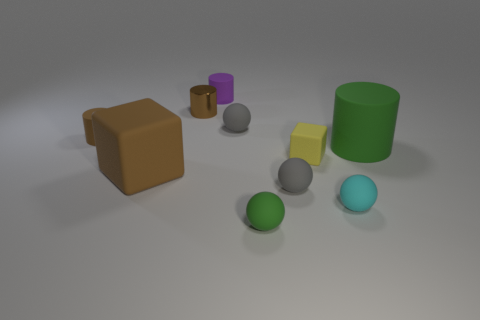Is there a red metal cube that has the same size as the yellow cube?
Your answer should be very brief. No. There is a cyan matte object; is it the same size as the cylinder to the right of the tiny purple rubber object?
Make the answer very short. No. Is the number of small metallic things in front of the cyan matte thing the same as the number of big green objects that are left of the purple rubber object?
Offer a very short reply. Yes. There is a tiny rubber thing that is the same color as the big cylinder; what is its shape?
Your answer should be very brief. Sphere. What is the green object behind the cyan object made of?
Give a very brief answer. Rubber. Does the brown metallic cylinder have the same size as the green matte sphere?
Give a very brief answer. Yes. Are there more things in front of the small purple cylinder than tiny yellow spheres?
Your response must be concise. Yes. What is the size of the brown cube that is made of the same material as the small green object?
Make the answer very short. Large. There is a large green rubber cylinder; are there any small green rubber spheres on the left side of it?
Provide a succinct answer. Yes. Is the tiny brown rubber thing the same shape as the tiny cyan rubber thing?
Provide a succinct answer. No. 